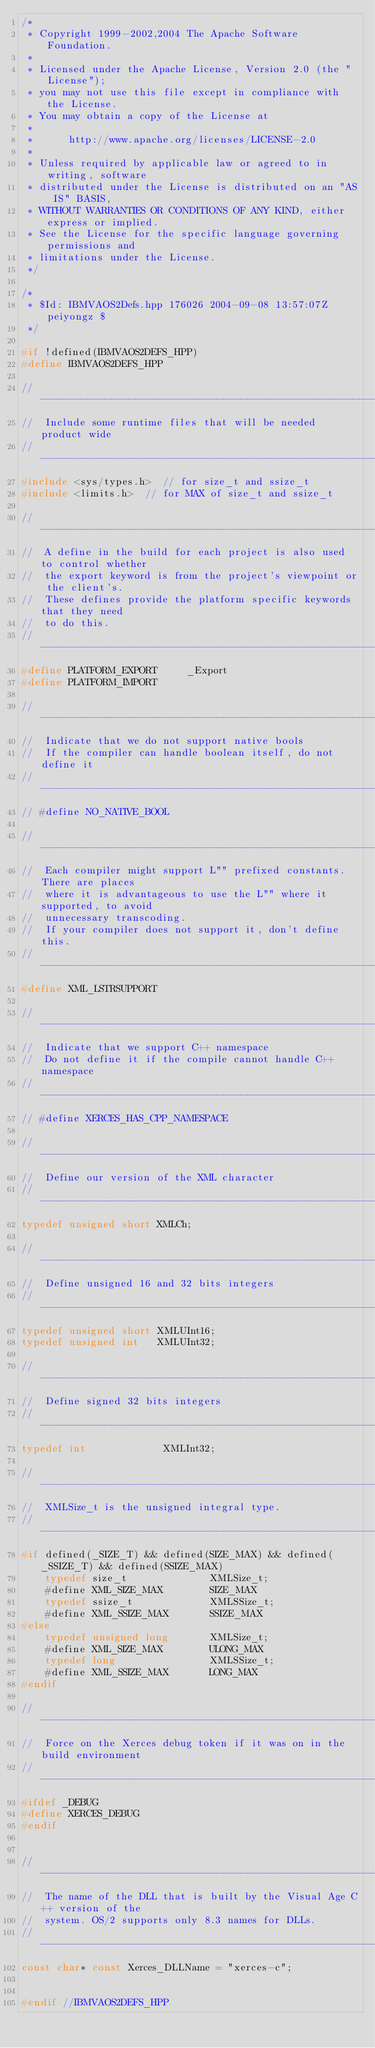Convert code to text. <code><loc_0><loc_0><loc_500><loc_500><_C++_>/*
 * Copyright 1999-2002,2004 The Apache Software Foundation.
 * 
 * Licensed under the Apache License, Version 2.0 (the "License");
 * you may not use this file except in compliance with the License.
 * You may obtain a copy of the License at
 * 
 *      http://www.apache.org/licenses/LICENSE-2.0
 * 
 * Unless required by applicable law or agreed to in writing, software
 * distributed under the License is distributed on an "AS IS" BASIS,
 * WITHOUT WARRANTIES OR CONDITIONS OF ANY KIND, either express or implied.
 * See the License for the specific language governing permissions and
 * limitations under the License.
 */

/*
 * $Id: IBMVAOS2Defs.hpp 176026 2004-09-08 13:57:07Z peiyongz $
 */

#if !defined(IBMVAOS2DEFS_HPP)
#define IBMVAOS2DEFS_HPP

// ---------------------------------------------------------------------------
//  Include some runtime files that will be needed product wide
// ---------------------------------------------------------------------------
#include <sys/types.h>  // for size_t and ssize_t
#include <limits.h>  // for MAX of size_t and ssize_t

// ---------------------------------------------------------------------------
//  A define in the build for each project is also used to control whether
//  the export keyword is from the project's viewpoint or the client's.
//  These defines provide the platform specific keywords that they need
//  to do this.
// ---------------------------------------------------------------------------
#define PLATFORM_EXPORT     _Export
#define PLATFORM_IMPORT

// ---------------------------------------------------------------------------
//  Indicate that we do not support native bools
//  If the compiler can handle boolean itself, do not define it
// ---------------------------------------------------------------------------
// #define NO_NATIVE_BOOL

// ---------------------------------------------------------------------------
//  Each compiler might support L"" prefixed constants. There are places
//  where it is advantageous to use the L"" where it supported, to avoid
//  unnecessary transcoding.
//  If your compiler does not support it, don't define this.
// ---------------------------------------------------------------------------
#define XML_LSTRSUPPORT

// ---------------------------------------------------------------------------
//  Indicate that we support C++ namespace
//  Do not define it if the compile cannot handle C++ namespace
// ---------------------------------------------------------------------------
// #define XERCES_HAS_CPP_NAMESPACE

// ---------------------------------------------------------------------------
//  Define our version of the XML character
// ---------------------------------------------------------------------------
typedef unsigned short XMLCh;

// ---------------------------------------------------------------------------
//  Define unsigned 16 and 32 bits integers
// ---------------------------------------------------------------------------
typedef unsigned short XMLUInt16;
typedef unsigned int   XMLUInt32;

// ---------------------------------------------------------------------------
//  Define signed 32 bits integers
// ---------------------------------------------------------------------------
typedef int             XMLInt32;

// ---------------------------------------------------------------------------
//  XMLSize_t is the unsigned integral type.
// ---------------------------------------------------------------------------
#if defined(_SIZE_T) && defined(SIZE_MAX) && defined(_SSIZE_T) && defined(SSIZE_MAX)
    typedef size_t              XMLSize_t;
    #define XML_SIZE_MAX        SIZE_MAX
    typedef ssize_t             XMLSSize_t;
    #define XML_SSIZE_MAX       SSIZE_MAX
#else
    typedef unsigned long       XMLSize_t;
    #define XML_SIZE_MAX        ULONG_MAX
    typedef long                XMLSSize_t;
    #define XML_SSIZE_MAX       LONG_MAX
#endif

// ---------------------------------------------------------------------------
//  Force on the Xerces debug token if it was on in the build environment
// ---------------------------------------------------------------------------
#ifdef _DEBUG
#define XERCES_DEBUG
#endif


// ---------------------------------------------------------------------------
//  The name of the DLL that is built by the Visual Age C++ version of the
//  system. OS/2 supports only 8.3 names for DLLs.
// ---------------------------------------------------------------------------
const char* const Xerces_DLLName = "xerces-c";


#endif //IBMVAOS2DEFS_HPP
</code> 